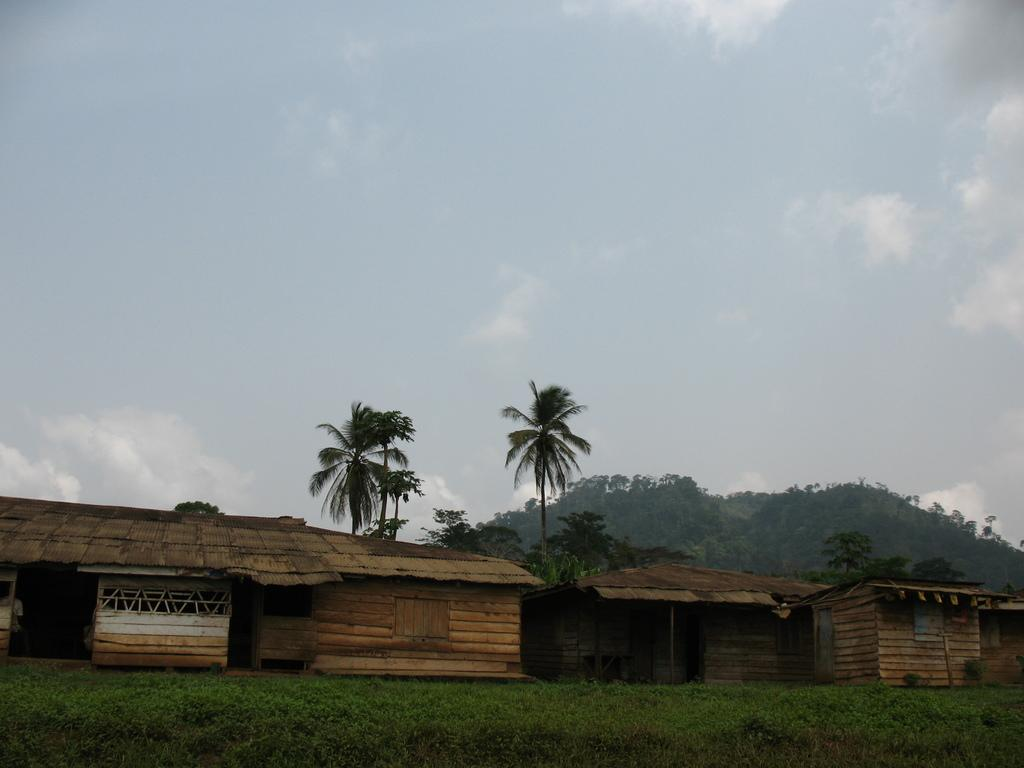What type of living organisms can be seen in the image? Plants can be seen in the image. What type of structures are present in the image? There are wooden houses in the image. What can be seen in the background of the image? Trees and a mountain are visible in the background of the image. What part of the natural environment is visible in the image? The sky is visible in the background of the image. What type of feather can be seen on the mountain in the image? There is no feather present on the mountain in the image. Can you tell me how many plane tickets are visible in the image? There are no plane tickets present in the image. 